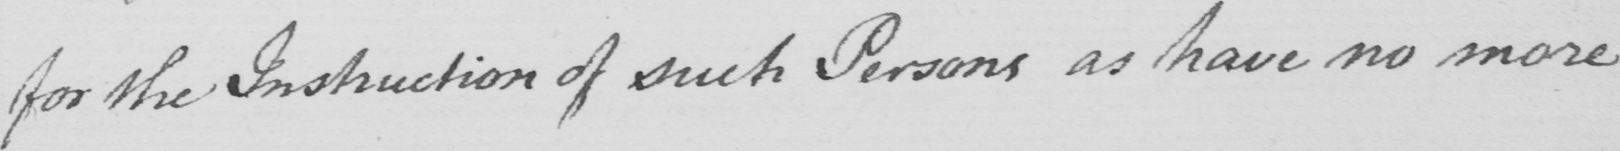Please provide the text content of this handwritten line. for the Instruction of such Persons as have no more 